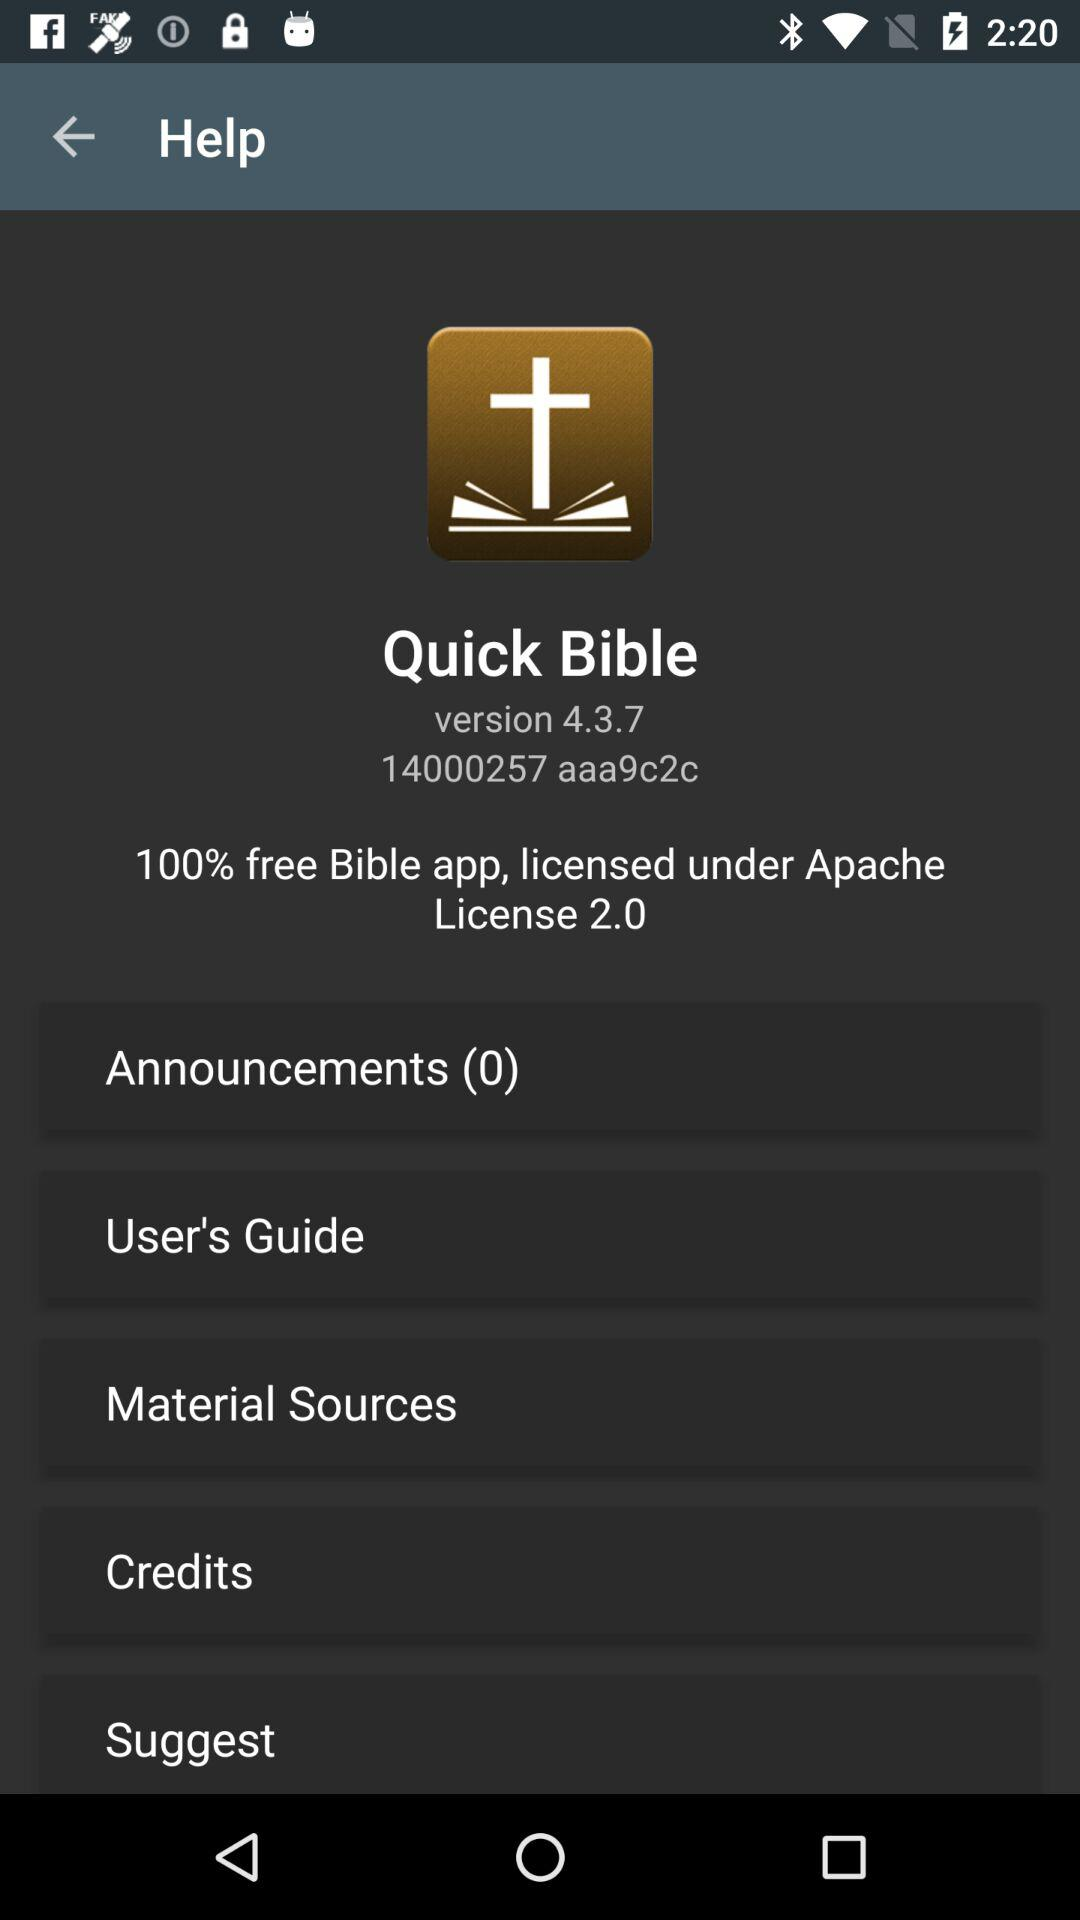Is this application is free?
When the provided information is insufficient, respond with <no answer>. <no answer> 